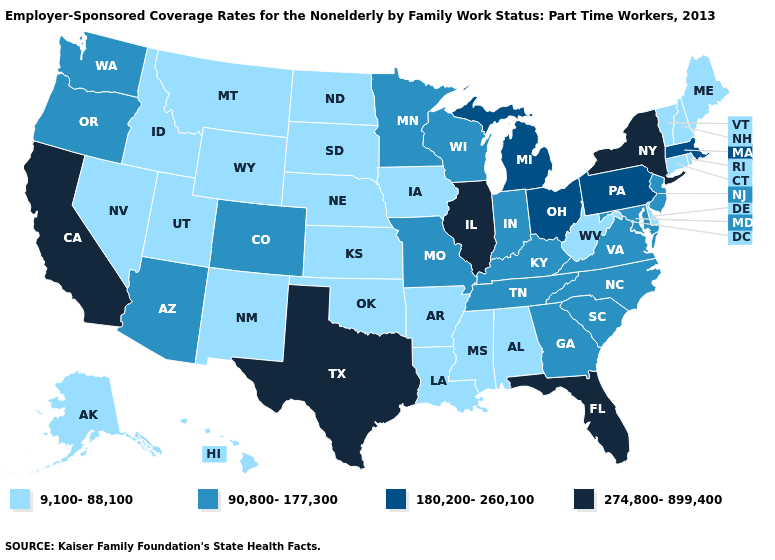Does West Virginia have the highest value in the USA?
Concise answer only. No. Which states have the lowest value in the MidWest?
Keep it brief. Iowa, Kansas, Nebraska, North Dakota, South Dakota. How many symbols are there in the legend?
Keep it brief. 4. Is the legend a continuous bar?
Write a very short answer. No. What is the lowest value in states that border Nevada?
Write a very short answer. 9,100-88,100. Name the states that have a value in the range 180,200-260,100?
Quick response, please. Massachusetts, Michigan, Ohio, Pennsylvania. What is the value of North Carolina?
Give a very brief answer. 90,800-177,300. What is the lowest value in the West?
Write a very short answer. 9,100-88,100. What is the value of Oklahoma?
Concise answer only. 9,100-88,100. What is the value of New York?
Write a very short answer. 274,800-899,400. Does West Virginia have the lowest value in the South?
Write a very short answer. Yes. Is the legend a continuous bar?
Write a very short answer. No. Does South Dakota have the lowest value in the USA?
Concise answer only. Yes. Name the states that have a value in the range 90,800-177,300?
Keep it brief. Arizona, Colorado, Georgia, Indiana, Kentucky, Maryland, Minnesota, Missouri, New Jersey, North Carolina, Oregon, South Carolina, Tennessee, Virginia, Washington, Wisconsin. 